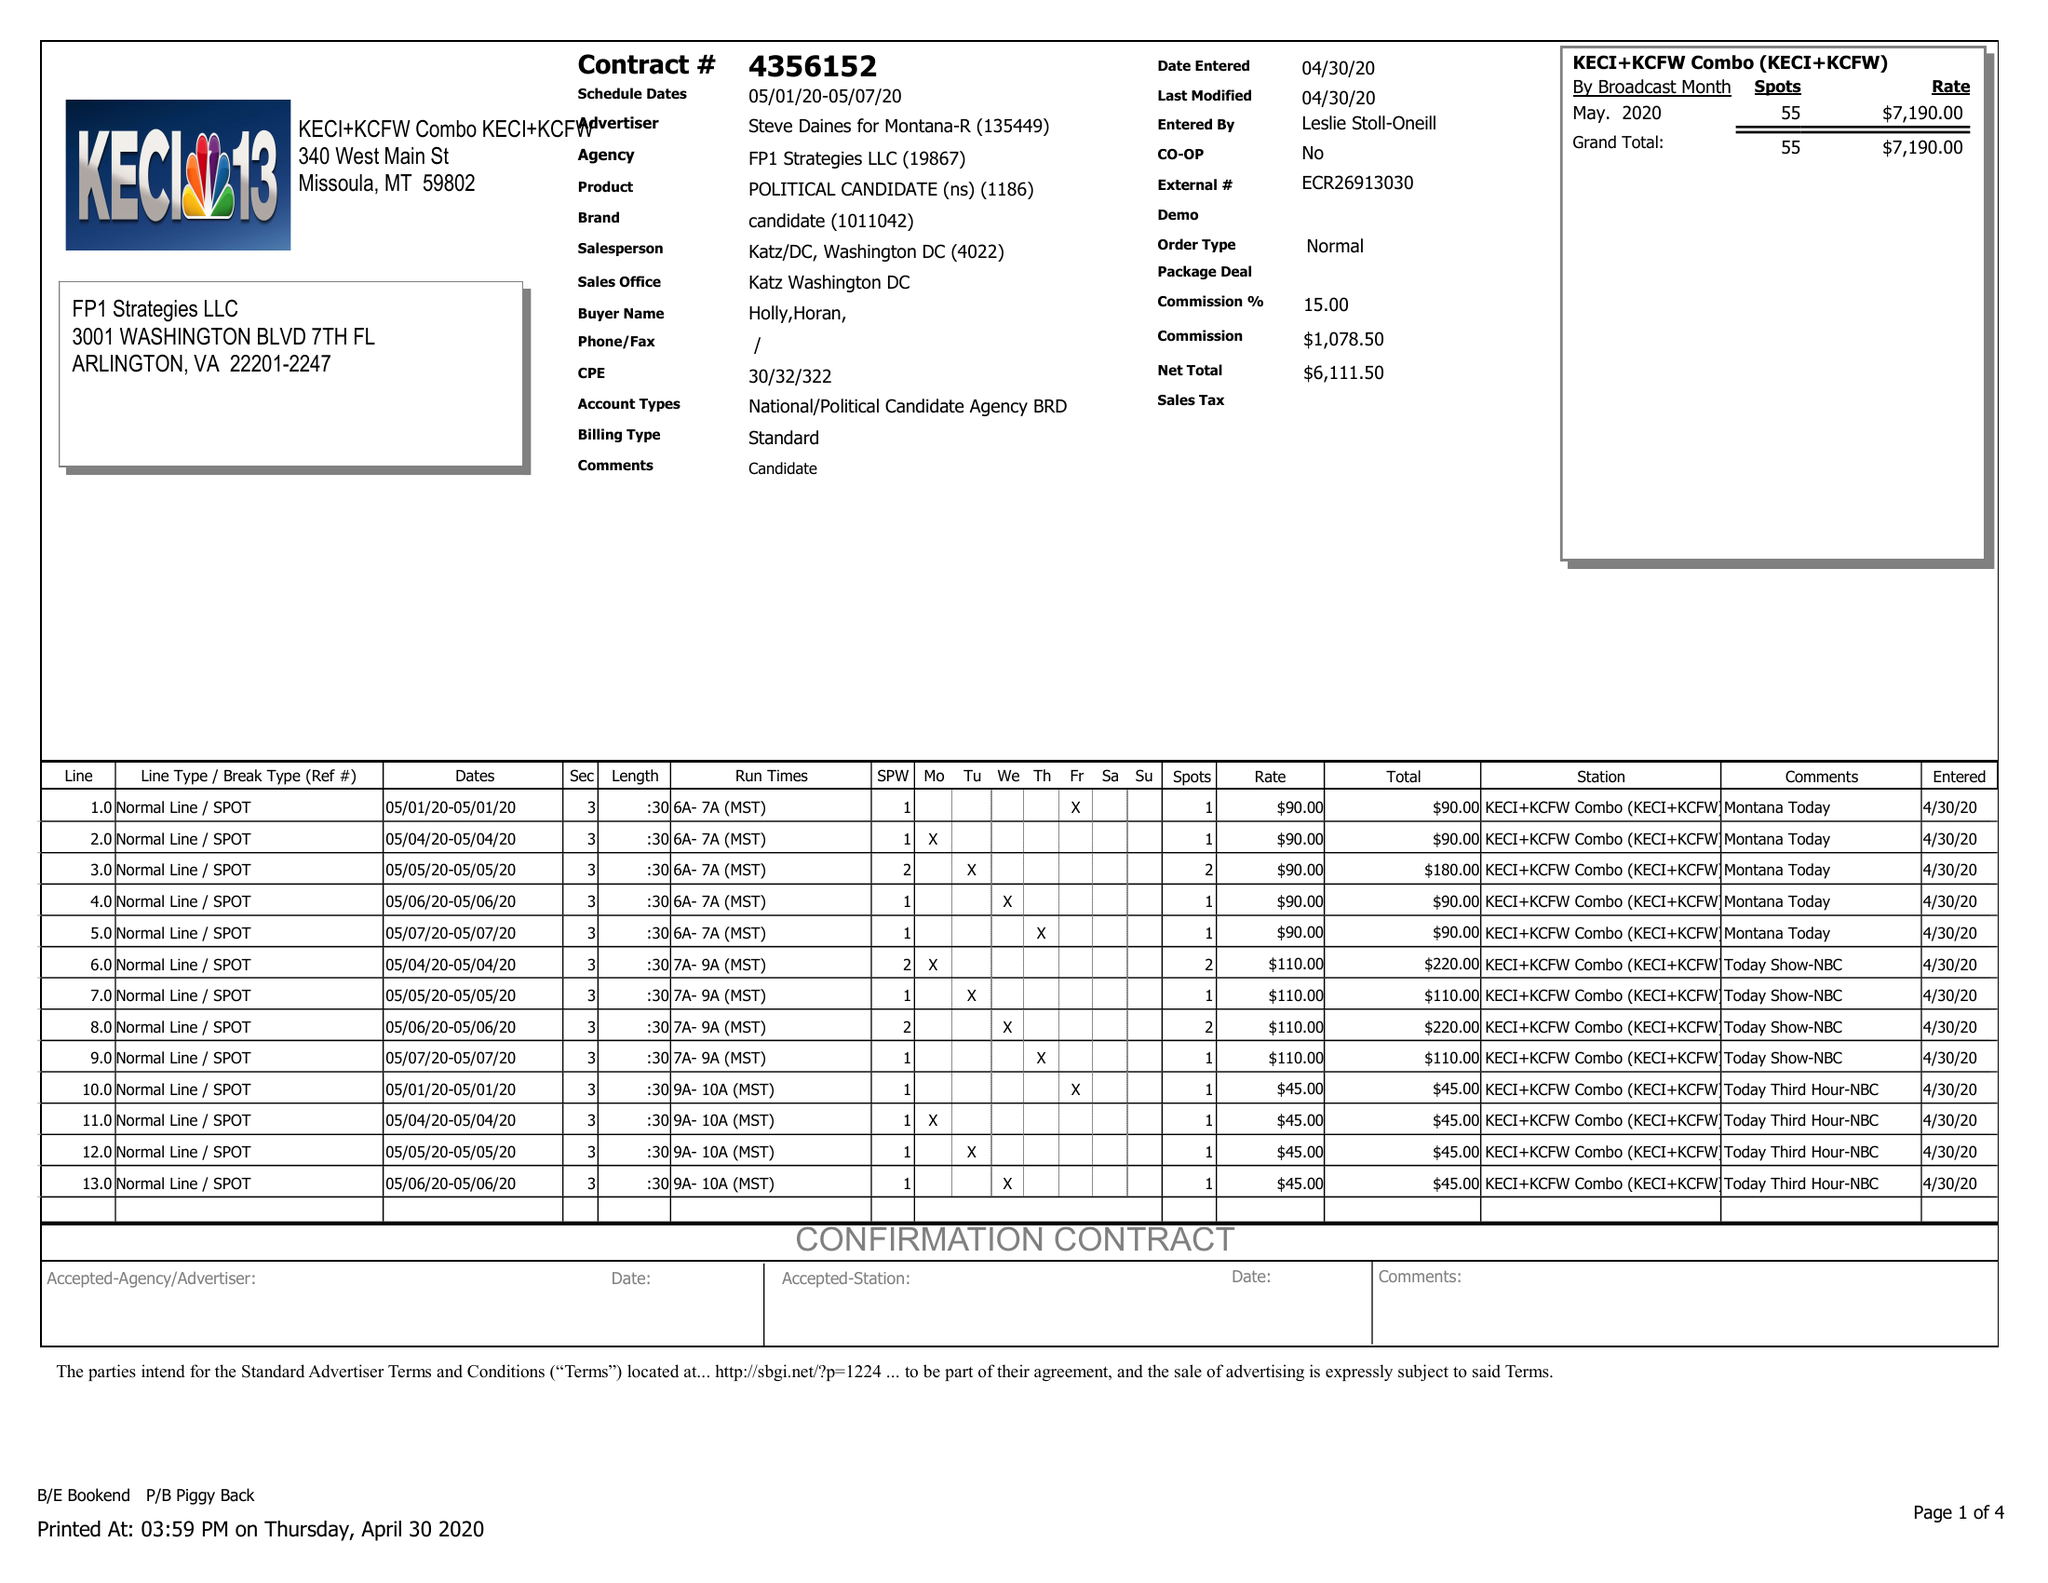What is the value for the flight_from?
Answer the question using a single word or phrase. 05/01/20 